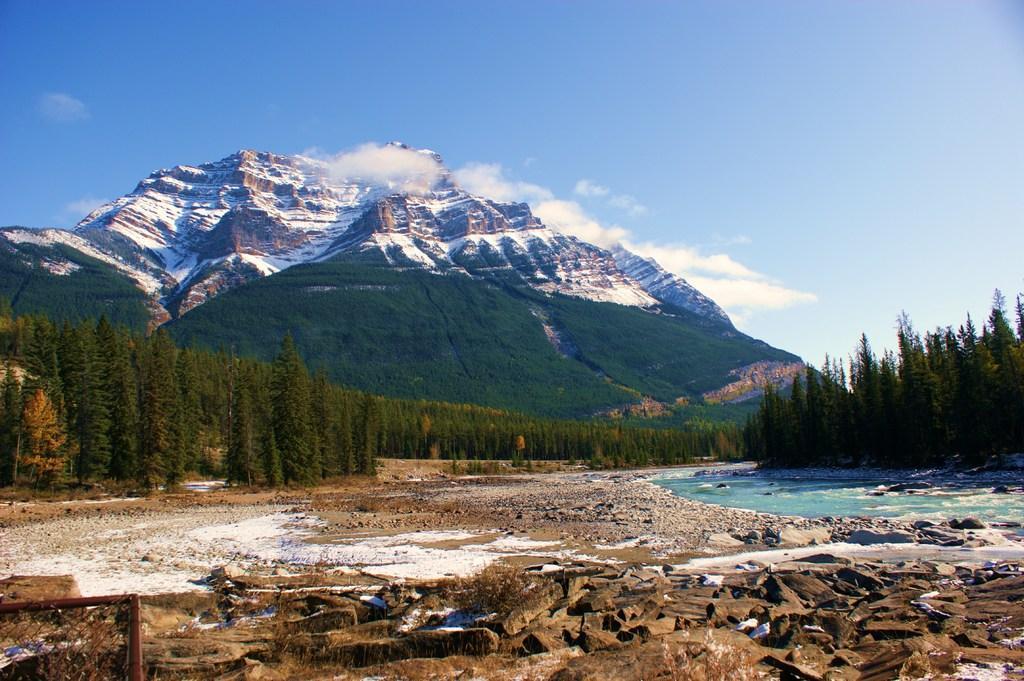Describe this image in one or two sentences. In this image we can see a land and a stream. In the background, we can see trees and the mountains. At the top of the image, we can see the sky. There is a mesh in the left bottom of the image. 